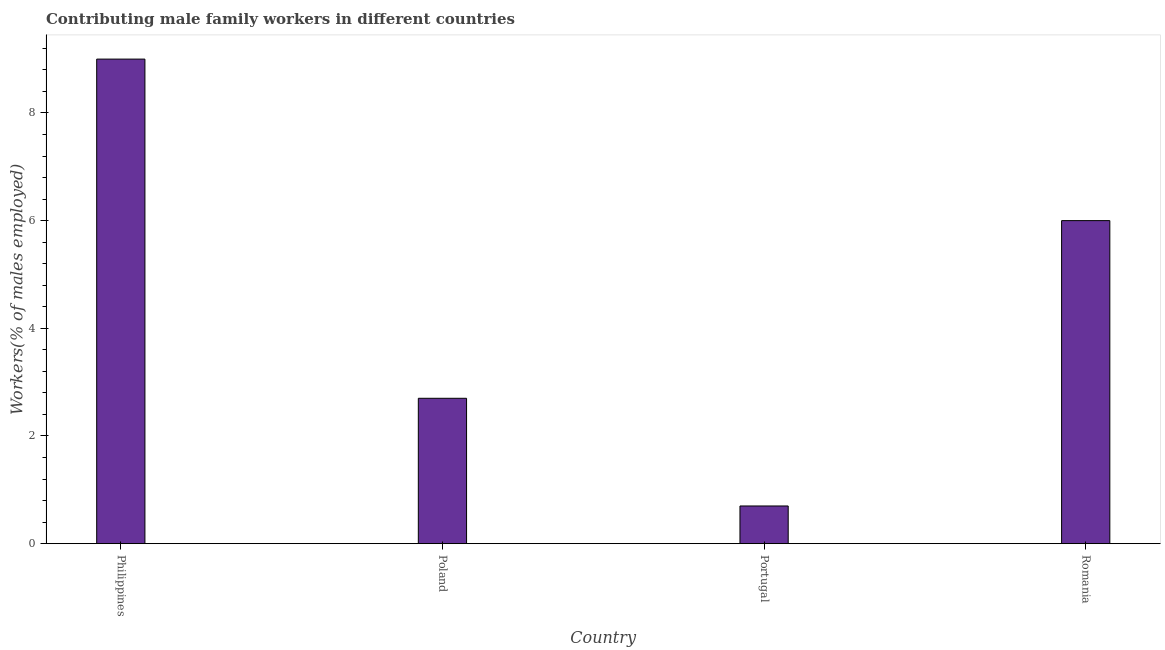Does the graph contain any zero values?
Make the answer very short. No. What is the title of the graph?
Provide a short and direct response. Contributing male family workers in different countries. What is the label or title of the Y-axis?
Your answer should be compact. Workers(% of males employed). What is the contributing male family workers in Poland?
Provide a succinct answer. 2.7. Across all countries, what is the minimum contributing male family workers?
Offer a terse response. 0.7. In which country was the contributing male family workers maximum?
Keep it short and to the point. Philippines. What is the sum of the contributing male family workers?
Provide a short and direct response. 18.4. What is the median contributing male family workers?
Your answer should be compact. 4.35. In how many countries, is the contributing male family workers greater than 8.4 %?
Your answer should be compact. 1. What is the ratio of the contributing male family workers in Poland to that in Portugal?
Offer a very short reply. 3.86. What is the difference between the highest and the second highest contributing male family workers?
Keep it short and to the point. 3. Is the sum of the contributing male family workers in Philippines and Portugal greater than the maximum contributing male family workers across all countries?
Keep it short and to the point. Yes. What is the difference between the highest and the lowest contributing male family workers?
Ensure brevity in your answer.  8.3. In how many countries, is the contributing male family workers greater than the average contributing male family workers taken over all countries?
Your answer should be very brief. 2. Are all the bars in the graph horizontal?
Ensure brevity in your answer.  No. What is the difference between two consecutive major ticks on the Y-axis?
Your response must be concise. 2. Are the values on the major ticks of Y-axis written in scientific E-notation?
Offer a terse response. No. What is the Workers(% of males employed) in Poland?
Give a very brief answer. 2.7. What is the Workers(% of males employed) in Portugal?
Offer a terse response. 0.7. What is the difference between the Workers(% of males employed) in Philippines and Poland?
Keep it short and to the point. 6.3. What is the difference between the Workers(% of males employed) in Philippines and Romania?
Provide a succinct answer. 3. What is the difference between the Workers(% of males employed) in Poland and Portugal?
Provide a short and direct response. 2. What is the difference between the Workers(% of males employed) in Poland and Romania?
Ensure brevity in your answer.  -3.3. What is the ratio of the Workers(% of males employed) in Philippines to that in Poland?
Give a very brief answer. 3.33. What is the ratio of the Workers(% of males employed) in Philippines to that in Portugal?
Offer a very short reply. 12.86. What is the ratio of the Workers(% of males employed) in Poland to that in Portugal?
Give a very brief answer. 3.86. What is the ratio of the Workers(% of males employed) in Poland to that in Romania?
Provide a succinct answer. 0.45. What is the ratio of the Workers(% of males employed) in Portugal to that in Romania?
Offer a very short reply. 0.12. 